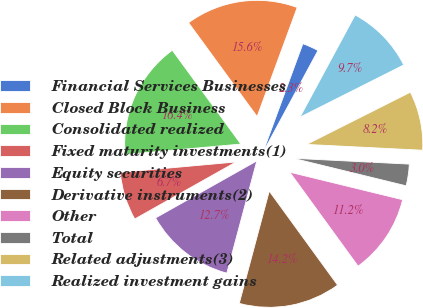Convert chart to OTSL. <chart><loc_0><loc_0><loc_500><loc_500><pie_chart><fcel>Financial Services Businesses<fcel>Closed Block Business<fcel>Consolidated realized<fcel>Fixed maturity investments(1)<fcel>Equity securities<fcel>Derivative instruments(2)<fcel>Other<fcel>Total<fcel>Related adjustments(3)<fcel>Realized investment gains<nl><fcel>2.27%<fcel>15.65%<fcel>16.39%<fcel>6.73%<fcel>12.68%<fcel>14.16%<fcel>11.19%<fcel>3.01%<fcel>8.22%<fcel>9.7%<nl></chart> 